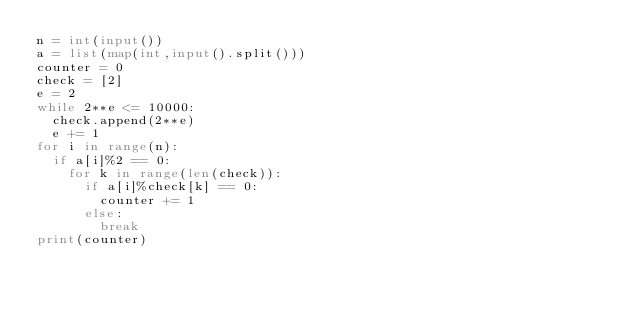<code> <loc_0><loc_0><loc_500><loc_500><_Python_>n = int(input())
a = list(map(int,input().split()))
counter = 0
check = [2]
e = 2
while 2**e <= 10000:
	check.append(2**e)
	e += 1
for i in range(n):
	if a[i]%2 == 0:
		for k in range(len(check)):
			if a[i]%check[k] == 0:
				counter += 1
			else:
				break
print(counter)</code> 